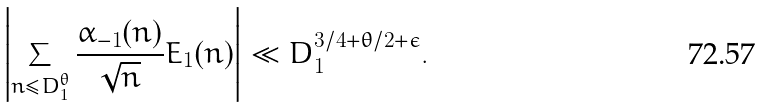<formula> <loc_0><loc_0><loc_500><loc_500>\left | \sum _ { n \leq D _ { 1 } ^ { \theta } } \frac { \alpha _ { - 1 } ( n ) } { \sqrt { n } } E _ { 1 } ( n ) \right | \ll D _ { 1 } ^ { 3 / 4 + \theta / 2 + \epsilon } .</formula> 